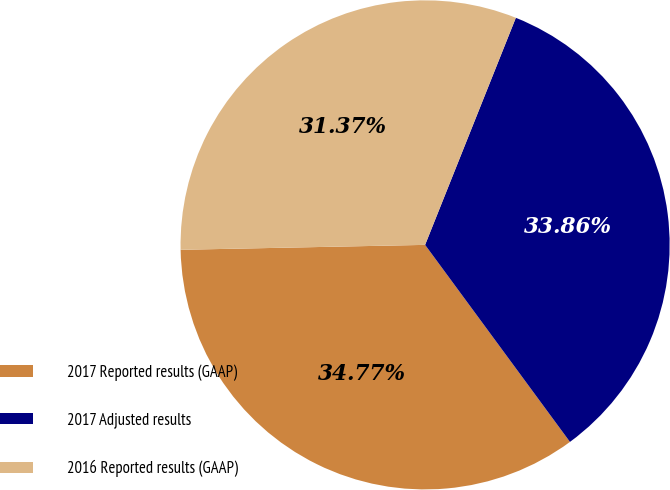Convert chart. <chart><loc_0><loc_0><loc_500><loc_500><pie_chart><fcel>2017 Reported results (GAAP)<fcel>2017 Adjusted results<fcel>2016 Reported results (GAAP)<nl><fcel>34.77%<fcel>33.86%<fcel>31.37%<nl></chart> 